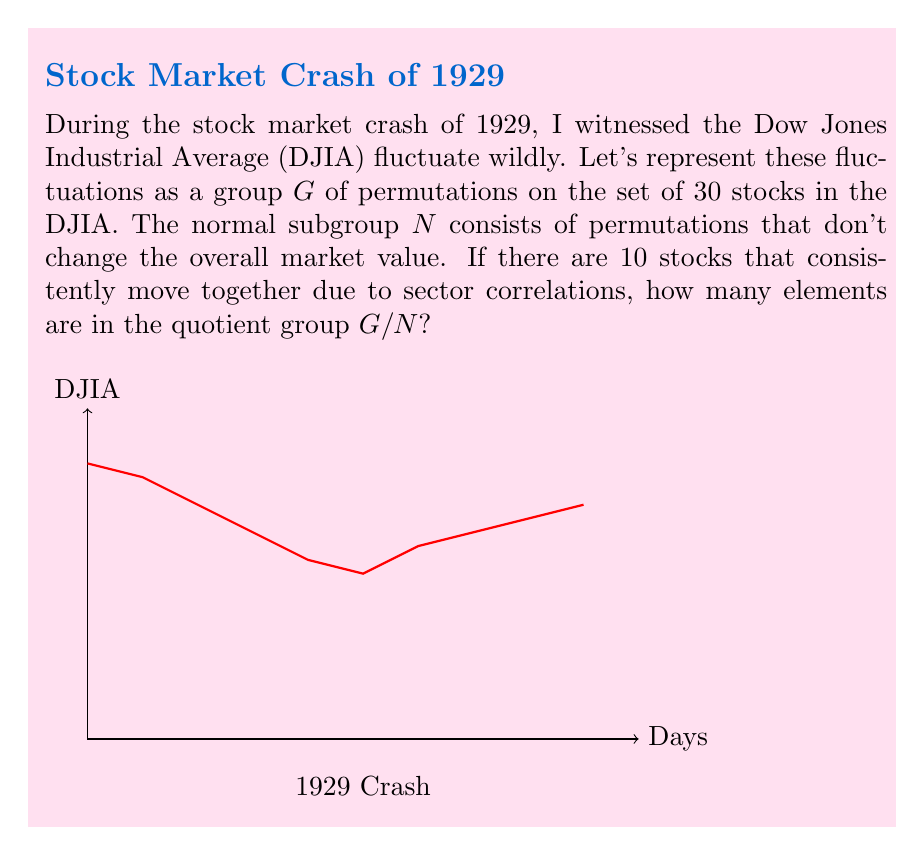Can you solve this math problem? Let's approach this step-by-step:

1) The group $G$ represents all permutations of the 30 stocks in the DJIA. The order of $G$ is thus $|G| = 30!$.

2) The normal subgroup $N$ consists of permutations that don't change the overall market value. This means $N$ can permute stocks within sectors that move together, but not between sectors.

3) We're told that 10 stocks consistently move together. This forms one sector. The remaining 20 stocks can be considered as individual sectors.

4) So, we have:
   - One sector of 10 stocks: $10!$ permutations
   - 20 individual stocks: each has $1!$ permutation

5) The order of $N$ is thus $|N| = 10! \cdot 1!^{20} = 10!$

6) The fundamental theorem of finite abelian groups states that for a normal subgroup $N$ of $G$:

   $$|G/N| = \frac{|G|}{|N|}$$

7) Substituting our values:

   $$|G/N| = \frac{30!}{10!} = \frac{30 \cdot 29 \cdot 28 \cdot ... \cdot 11}{1} = 30 \cdot 29 \cdot 28 \cdot ... \cdot 11$$

8) This can be written more concisely as:

   $$|G/N| = \frac{30!}{10!} = \frac{30!}{(10!)(20!)} \cdot 20! = \binom{30}{10} \cdot 20!$$
Answer: $\binom{30}{10} \cdot 20!$ 